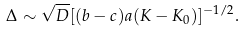Convert formula to latex. <formula><loc_0><loc_0><loc_500><loc_500>\Delta \sim \sqrt { D } [ ( b - c ) a ( K - K _ { 0 } ) ] ^ { - 1 / 2 } .</formula> 